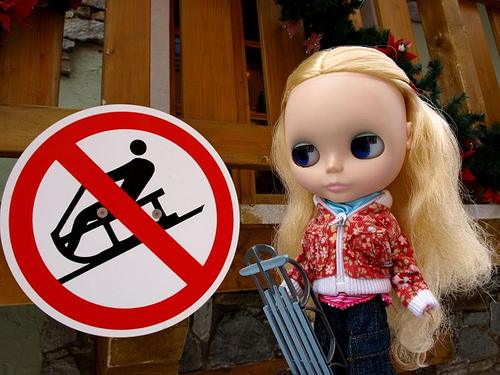<image>
Can you confirm if the board is to the right of the doll? Yes. From this viewpoint, the board is positioned to the right side relative to the doll. Is there a sign behind the doll? No. The sign is not behind the doll. From this viewpoint, the sign appears to be positioned elsewhere in the scene. 